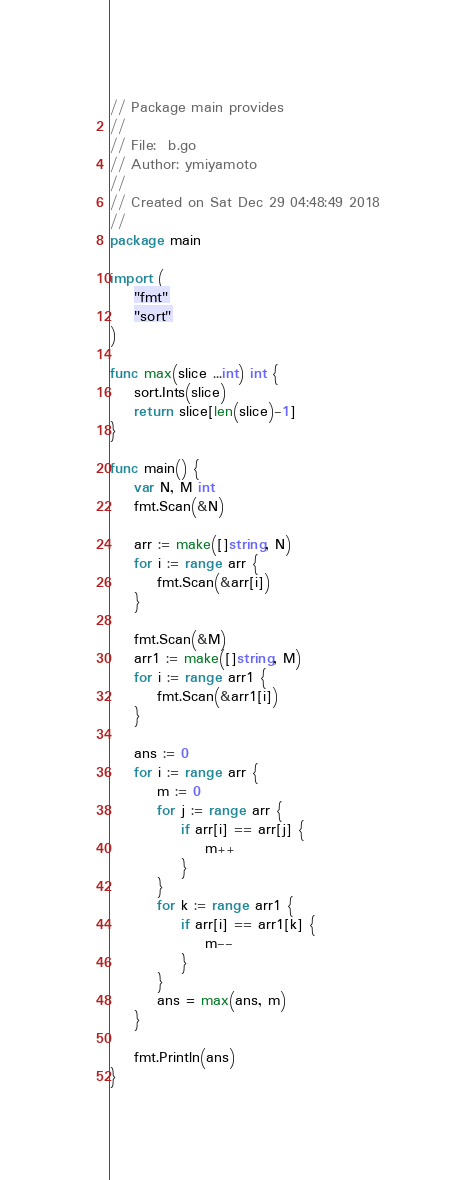<code> <loc_0><loc_0><loc_500><loc_500><_Go_>// Package main provides
//
// File:  b.go
// Author: ymiyamoto
//
// Created on Sat Dec 29 04:48:49 2018
//
package main

import (
	"fmt"
	"sort"
)

func max(slice ...int) int {
	sort.Ints(slice)
	return slice[len(slice)-1]
}

func main() {
	var N, M int
	fmt.Scan(&N)

	arr := make([]string, N)
	for i := range arr {
		fmt.Scan(&arr[i])
	}

	fmt.Scan(&M)
	arr1 := make([]string, M)
	for i := range arr1 {
		fmt.Scan(&arr1[i])
	}

	ans := 0
	for i := range arr {
		m := 0
		for j := range arr {
			if arr[i] == arr[j] {
				m++
			}
		}
		for k := range arr1 {
			if arr[i] == arr1[k] {
				m--
			}
		}
		ans = max(ans, m)
	}

	fmt.Println(ans)
}
</code> 